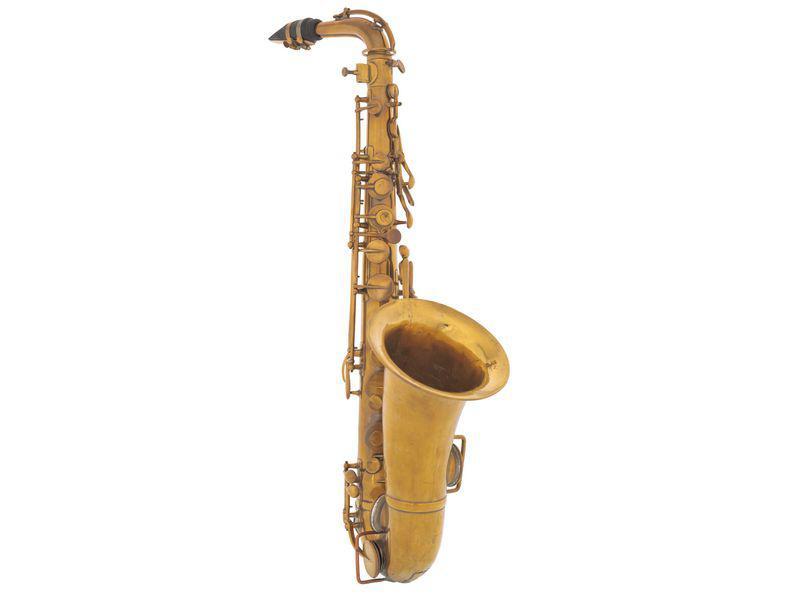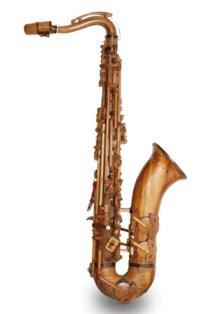The first image is the image on the left, the second image is the image on the right. Analyze the images presented: Is the assertion "The saxophone in one of the images is on a stand." valid? Answer yes or no. No. The first image is the image on the left, the second image is the image on the right. Analyze the images presented: Is the assertion "An image shows a wooden bamboo on a stand with light behind it creating deep shadow." valid? Answer yes or no. No. 